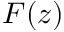Convert formula to latex. <formula><loc_0><loc_0><loc_500><loc_500>F ( z )</formula> 